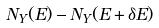Convert formula to latex. <formula><loc_0><loc_0><loc_500><loc_500>N _ { Y } ( E ) - N _ { Y } ( E + \delta E )</formula> 